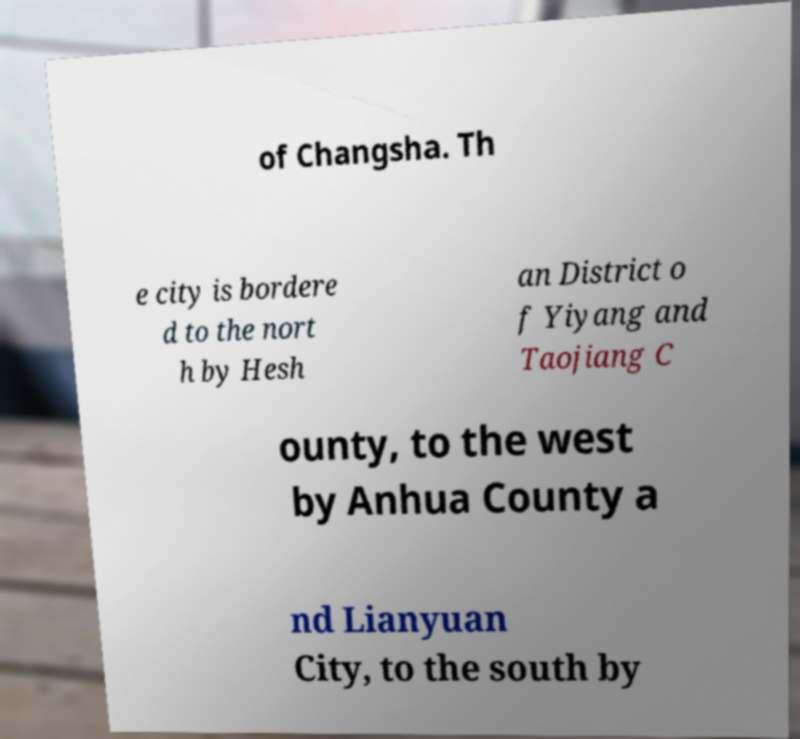Could you extract and type out the text from this image? of Changsha. Th e city is bordere d to the nort h by Hesh an District o f Yiyang and Taojiang C ounty, to the west by Anhua County a nd Lianyuan City, to the south by 